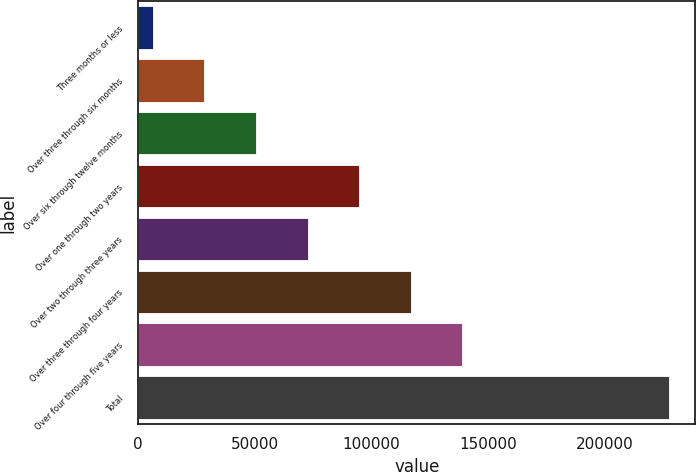Convert chart. <chart><loc_0><loc_0><loc_500><loc_500><bar_chart><fcel>Three months or less<fcel>Over three through six months<fcel>Over six through twelve months<fcel>Over one through two years<fcel>Over two through three years<fcel>Over three through four years<fcel>Over four through five years<fcel>Total<nl><fcel>6206<fcel>28331.2<fcel>50456.4<fcel>94706.8<fcel>72581.6<fcel>116832<fcel>138957<fcel>227458<nl></chart> 